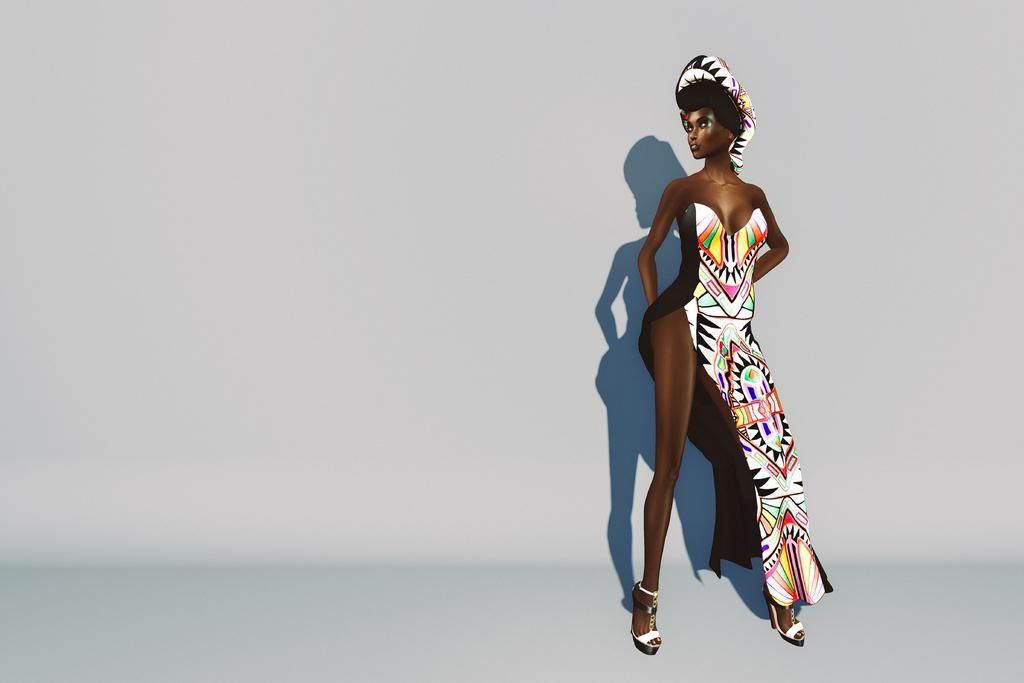What type of image is depicted in the picture? The image is a graphical image. Can you describe the main subject of the image? There is a cartoon of a woman in the image. What additional detail can be observed about the woman in the image? The woman's shadow is visible in the image. What is the background of the image? The background of the image is a plane. How many apples are being used to sew the woman's dress in the image? There are no apples present in the image, nor is there any indication that the woman's dress is being sewn. 